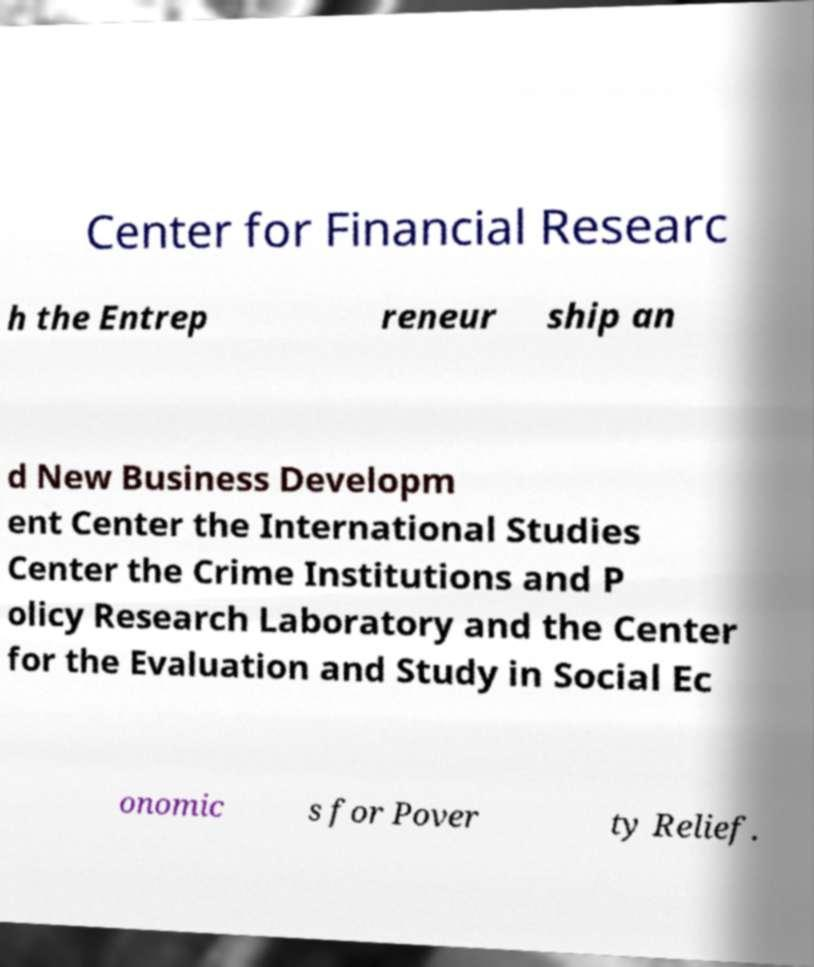For documentation purposes, I need the text within this image transcribed. Could you provide that? Center for Financial Researc h the Entrep reneur ship an d New Business Developm ent Center the International Studies Center the Crime Institutions and P olicy Research Laboratory and the Center for the Evaluation and Study in Social Ec onomic s for Pover ty Relief. 